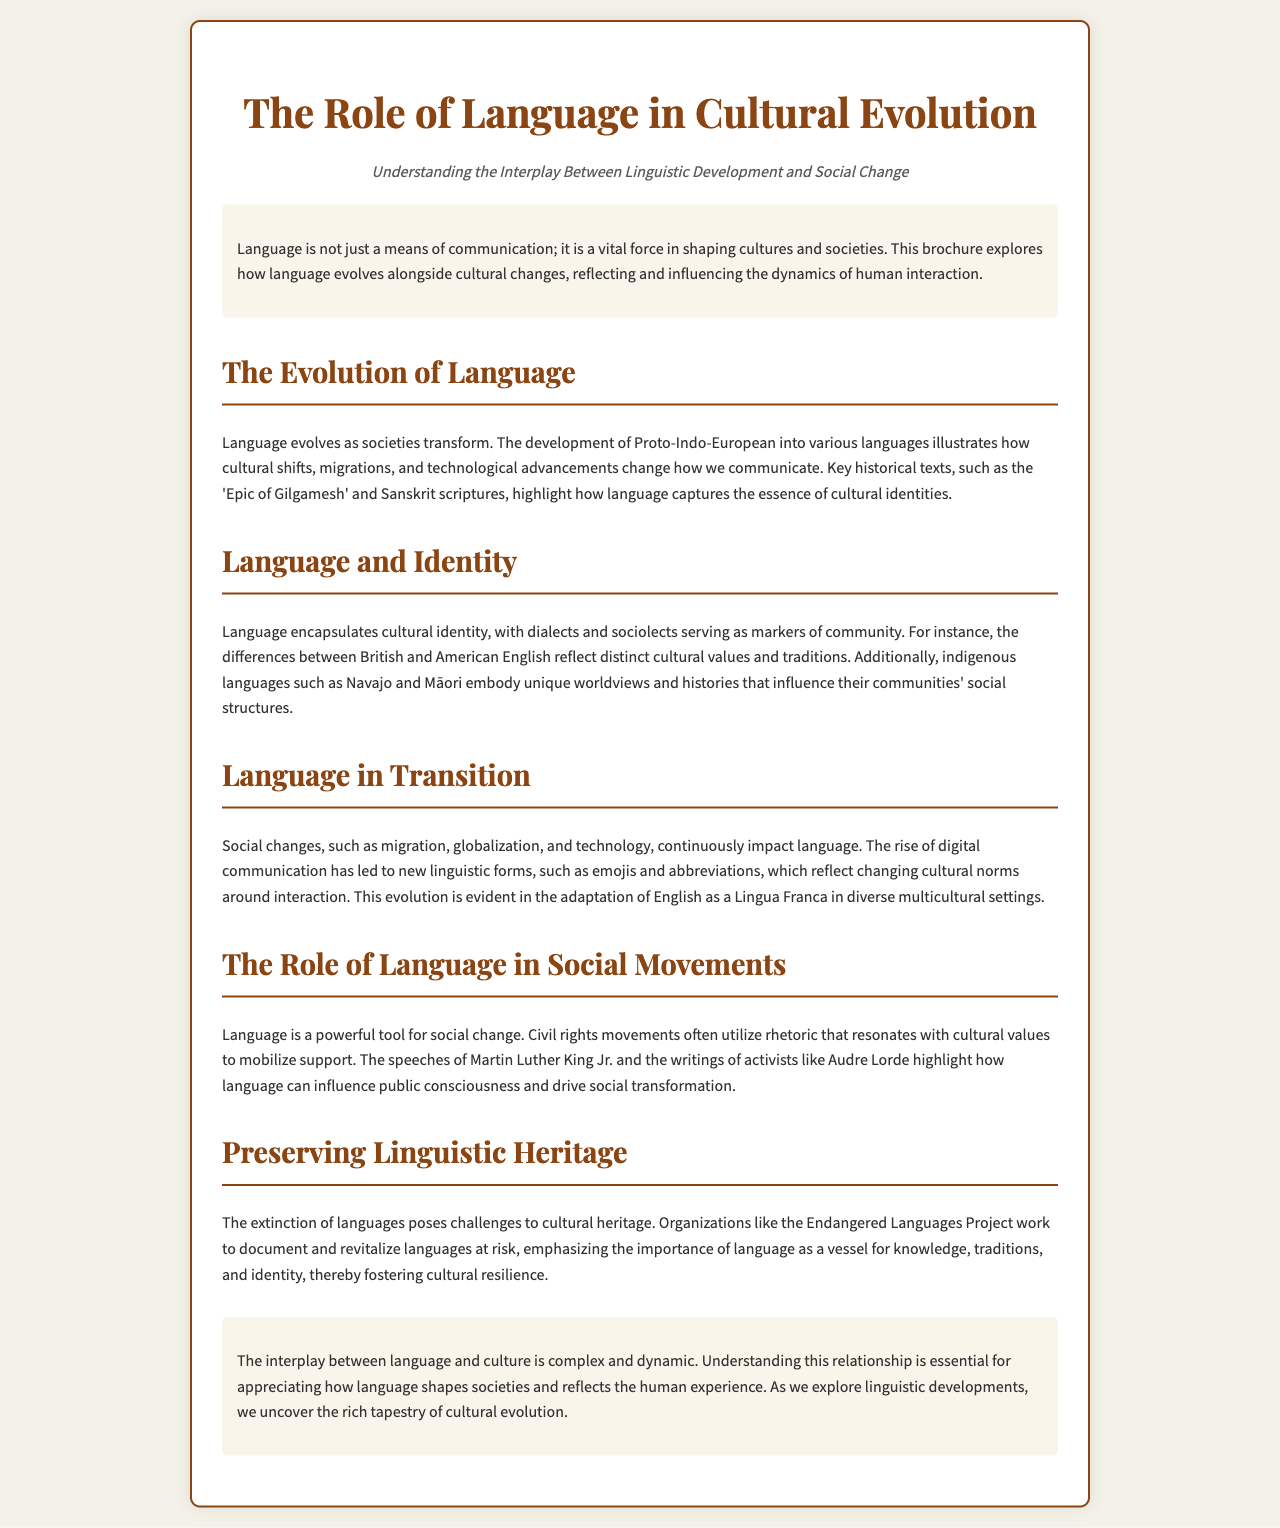What is the title of the brochure? The title of the brochure, as stated in the document, is the main heading that summarizes its contents.
Answer: The Role of Language in Cultural Evolution What does the brochure explore? The brochure discusses the relationship between language and cultural changes, emphasizing the significance of linguistic development.
Answer: How language evolves alongside cultural changes Which historical texts are mentioned? The brochure references specific texts to illustrate the evolution of language, highlighting their cultural importance.
Answer: 'Epic of Gilgamesh' and Sanskrit scriptures What impact does migration have on language? Migration is noted as one of the social changes that continuously affect linguistic development in different settings.
Answer: It impacts language evolution Who are two figures mentioned in relation to social movements? The brochure provides examples of influential individuals whose language usage has contributed to social advocacy.
Answer: Martin Luther King Jr. and Audre Lorde What organization works to preserve endangered languages? The document mentions a specific organization dedicated to documenting and revitalizing at-risk languages, highlighting its role in cultural heritage.
Answer: The Endangered Languages Project How does language reflect cultural identity? The brochure explains that dialects and sociolects serve as important markers of a community's cultural identity.
Answer: Through dialects and sociolects What is emphasized as vital in preserving cultural heritage? The document discusses the importance of language in sustaining knowledge, traditions, and identity in different populations.
Answer: Language as a vessel for knowledge What is the main conclusion of the brochure? The conclusion summarizes the complex relationship between language and culture, underlining its significance in understanding societal evolution.
Answer: Language shapes societies and reflects the human experience 